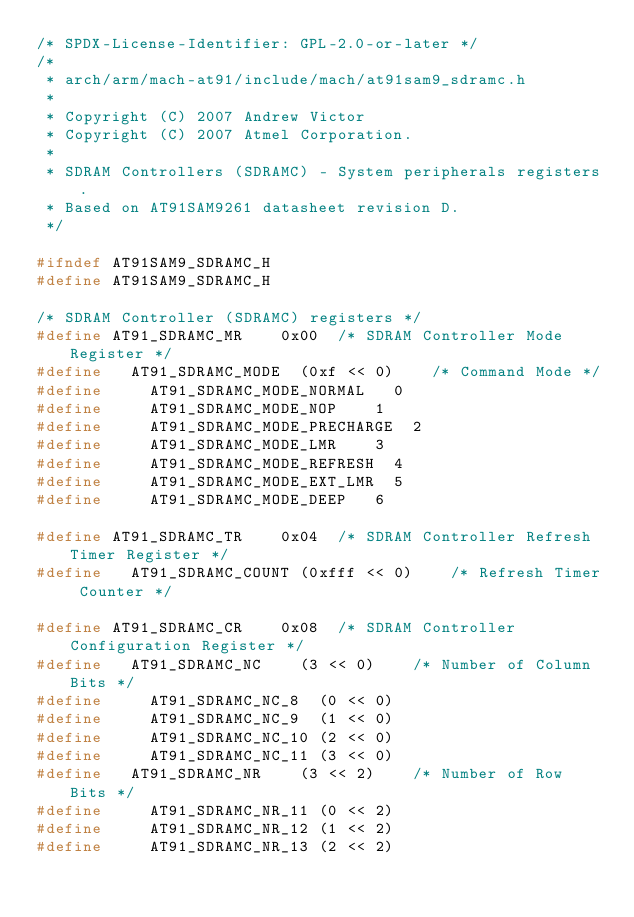<code> <loc_0><loc_0><loc_500><loc_500><_C_>/* SPDX-License-Identifier: GPL-2.0-or-later */
/*
 * arch/arm/mach-at91/include/mach/at91sam9_sdramc.h
 *
 * Copyright (C) 2007 Andrew Victor
 * Copyright (C) 2007 Atmel Corporation.
 *
 * SDRAM Controllers (SDRAMC) - System peripherals registers.
 * Based on AT91SAM9261 datasheet revision D.
 */

#ifndef AT91SAM9_SDRAMC_H
#define AT91SAM9_SDRAMC_H

/* SDRAM Controller (SDRAMC) registers */
#define AT91_SDRAMC_MR		0x00	/* SDRAM Controller Mode Register */
#define		AT91_SDRAMC_MODE	(0xf << 0)		/* Command Mode */
#define			AT91_SDRAMC_MODE_NORMAL		0
#define			AT91_SDRAMC_MODE_NOP		1
#define			AT91_SDRAMC_MODE_PRECHARGE	2
#define			AT91_SDRAMC_MODE_LMR		3
#define			AT91_SDRAMC_MODE_REFRESH	4
#define			AT91_SDRAMC_MODE_EXT_LMR	5
#define			AT91_SDRAMC_MODE_DEEP		6

#define AT91_SDRAMC_TR		0x04	/* SDRAM Controller Refresh Timer Register */
#define		AT91_SDRAMC_COUNT	(0xfff << 0)		/* Refresh Timer Counter */

#define AT91_SDRAMC_CR		0x08	/* SDRAM Controller Configuration Register */
#define		AT91_SDRAMC_NC		(3 << 0)		/* Number of Column Bits */
#define			AT91_SDRAMC_NC_8	(0 << 0)
#define			AT91_SDRAMC_NC_9	(1 << 0)
#define			AT91_SDRAMC_NC_10	(2 << 0)
#define			AT91_SDRAMC_NC_11	(3 << 0)
#define		AT91_SDRAMC_NR		(3 << 2)		/* Number of Row Bits */
#define			AT91_SDRAMC_NR_11	(0 << 2)
#define			AT91_SDRAMC_NR_12	(1 << 2)
#define			AT91_SDRAMC_NR_13	(2 << 2)</code> 